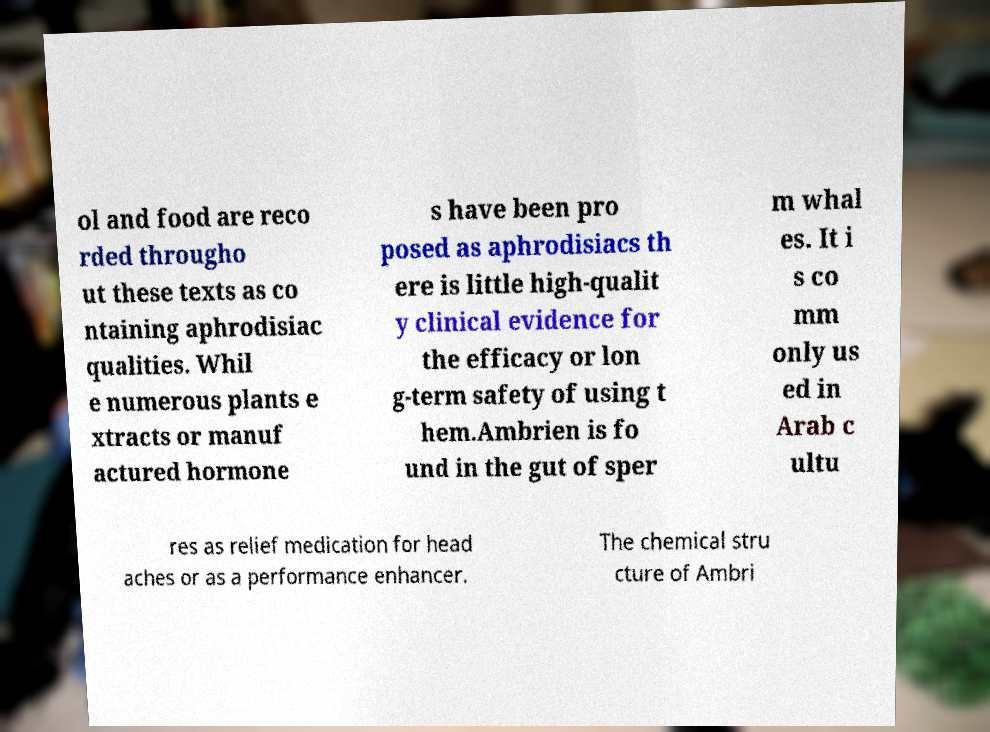Please read and relay the text visible in this image. What does it say? ol and food are reco rded througho ut these texts as co ntaining aphrodisiac qualities. Whil e numerous plants e xtracts or manuf actured hormone s have been pro posed as aphrodisiacs th ere is little high-qualit y clinical evidence for the efficacy or lon g-term safety of using t hem.Ambrien is fo und in the gut of sper m whal es. It i s co mm only us ed in Arab c ultu res as relief medication for head aches or as a performance enhancer. The chemical stru cture of Ambri 